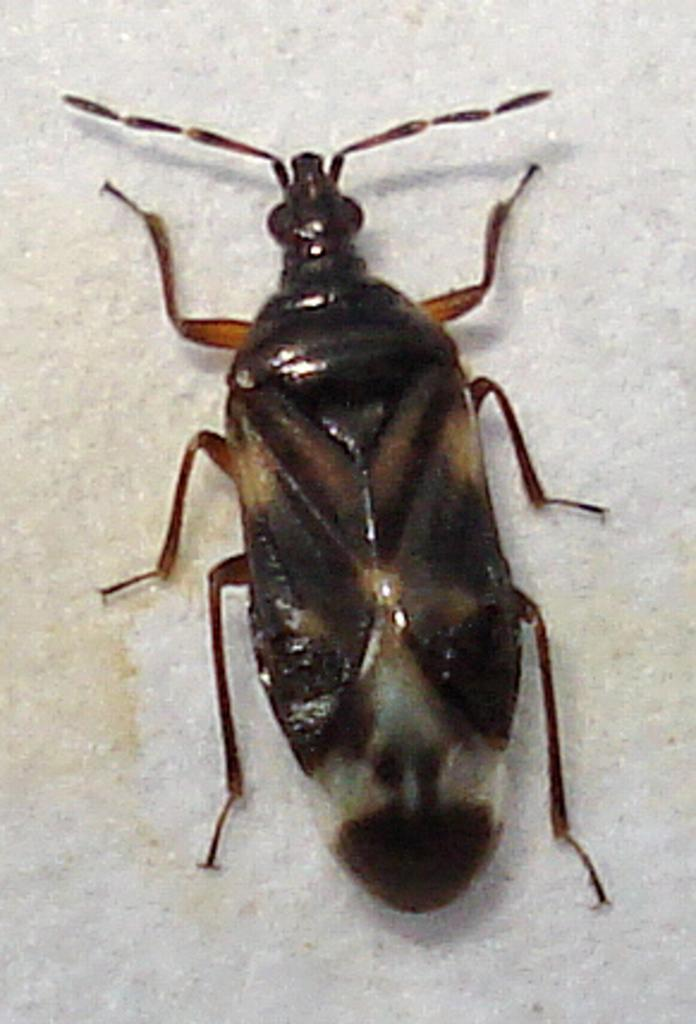What is the main subject of the image? There is a cockroach in the image. Where is the cockroach located? The cockroach is on the wall. What type of plants can be seen growing on the wall in the image? There are no plants visible in the image; it features a cockroach on the wall. What level of the building is the cockroach on in the image? The image does not provide information about the level of the building, only that the cockroach is on the wall. 